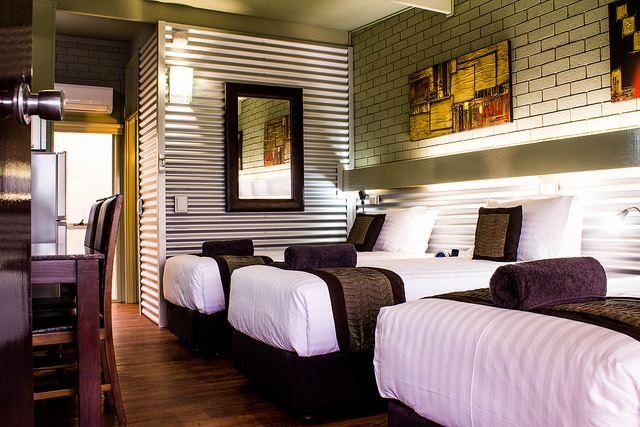Describe the objects in this image and their specific colors. I can see bed in black, lavender, darkgray, and maroon tones, bed in black, pink, and lavender tones, chair in black, maroon, brown, and gray tones, dining table in black, maroon, purple, and lightgray tones, and refrigerator in black, lavender, darkgray, brown, and gray tones in this image. 